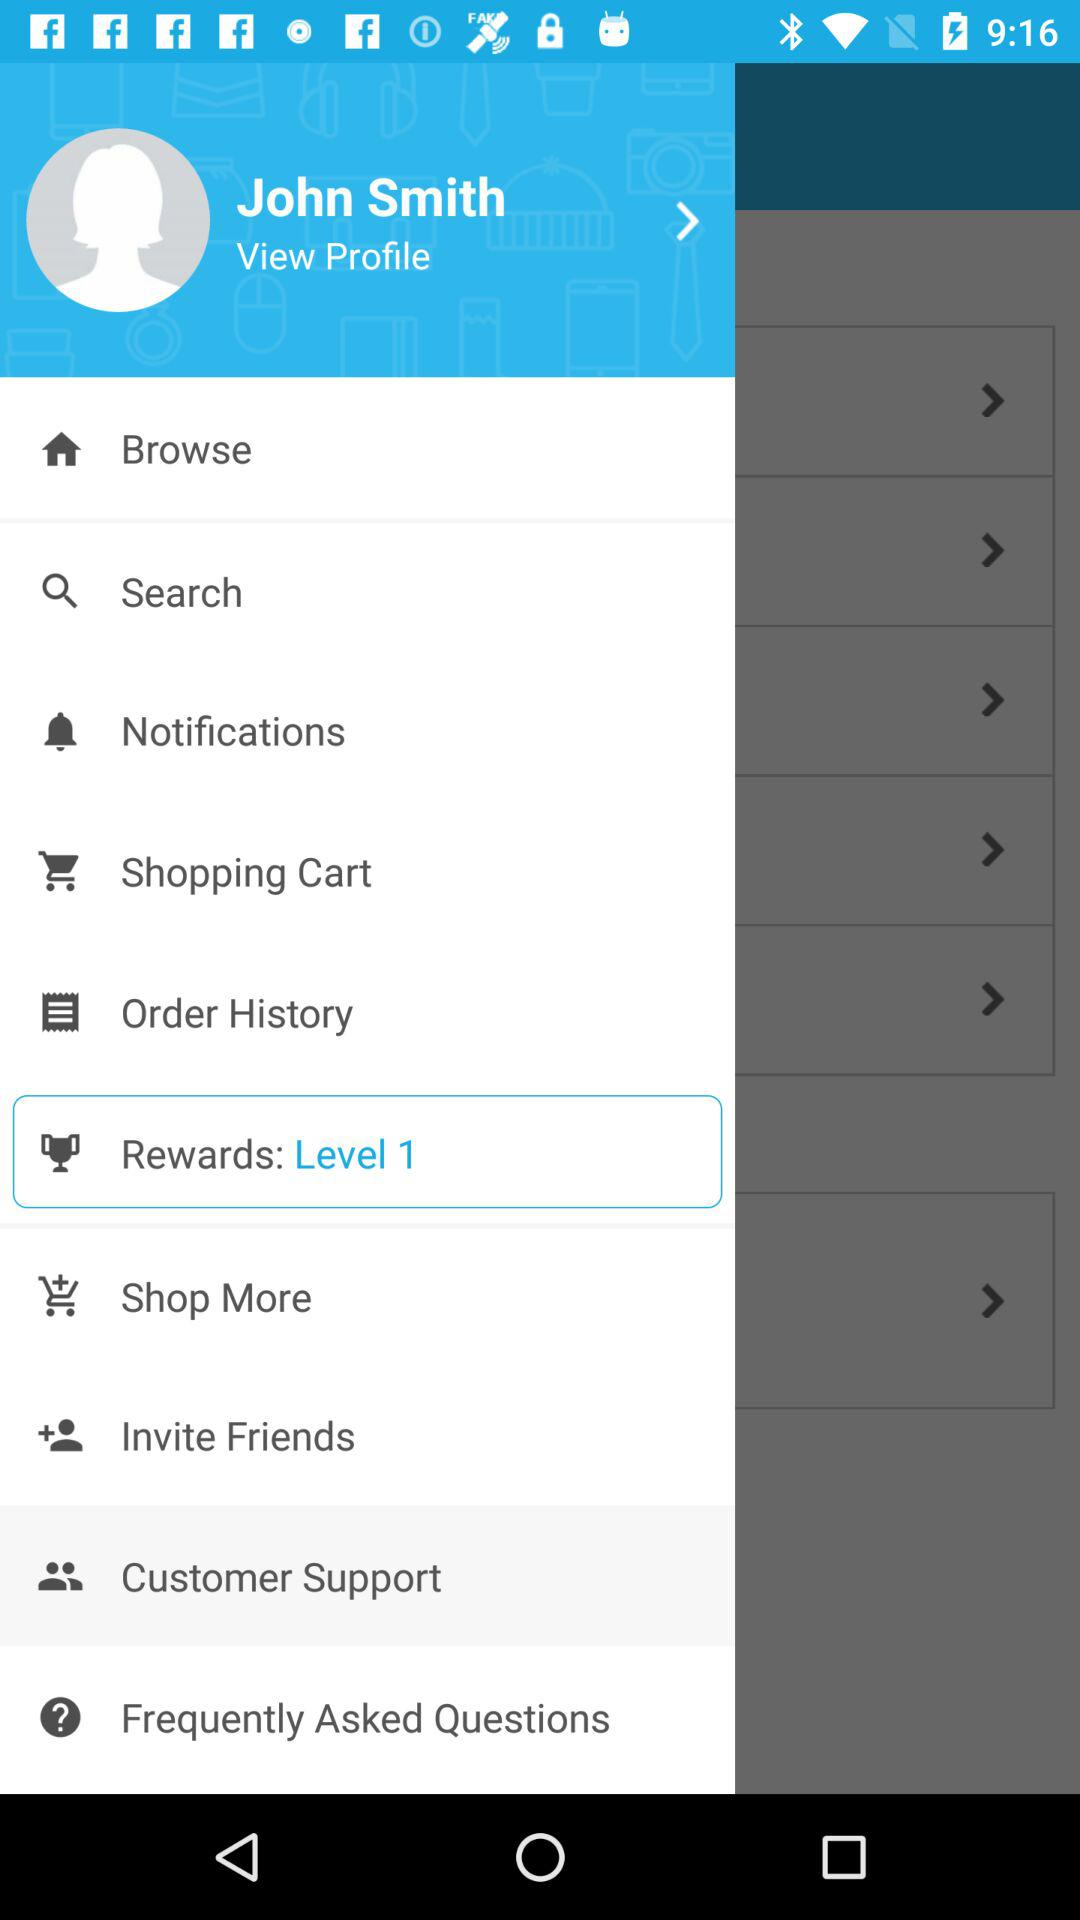What option has been selected? The selected option is "Customer Support". 